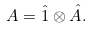Convert formula to latex. <formula><loc_0><loc_0><loc_500><loc_500>A = \hat { 1 } \otimes \hat { A } .</formula> 